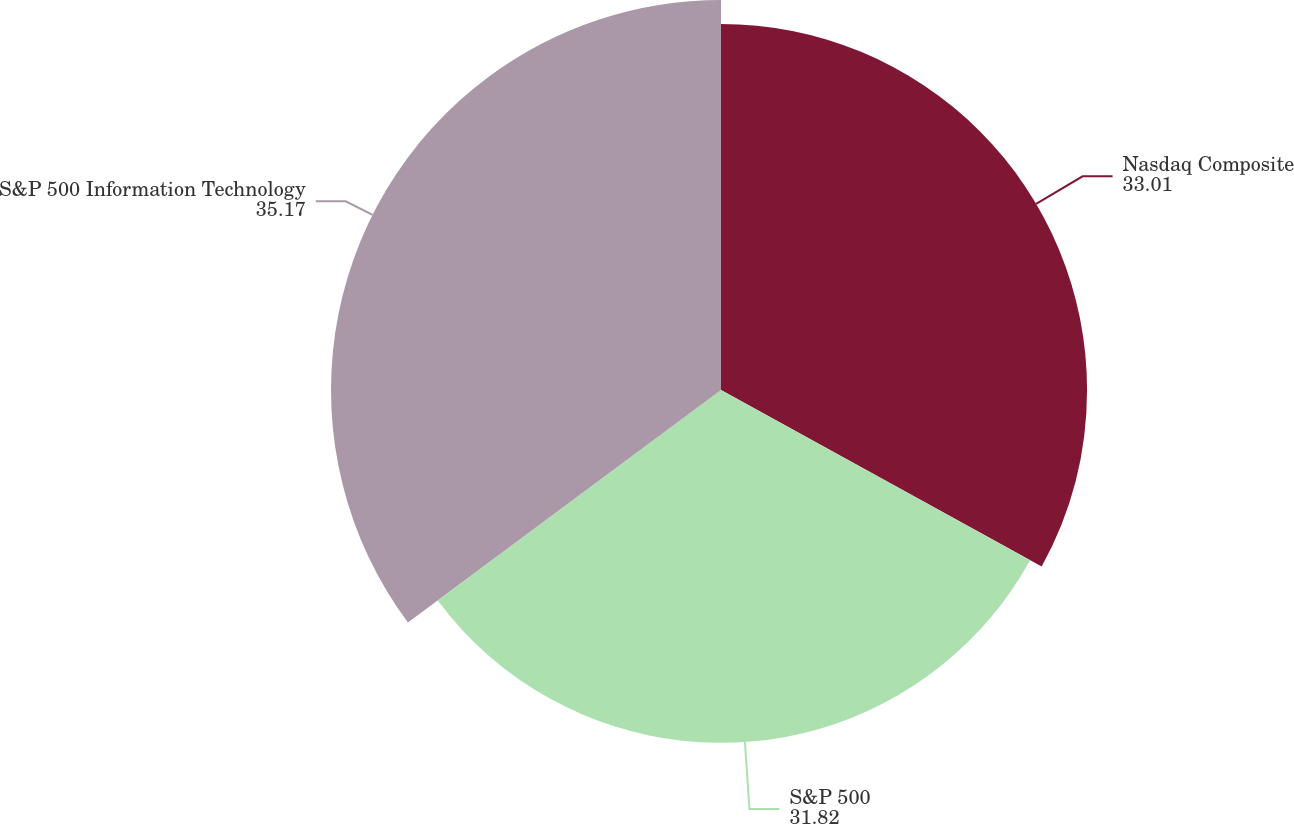Convert chart. <chart><loc_0><loc_0><loc_500><loc_500><pie_chart><fcel>Nasdaq Composite<fcel>S&P 500<fcel>S&P 500 Information Technology<nl><fcel>33.01%<fcel>31.82%<fcel>35.17%<nl></chart> 